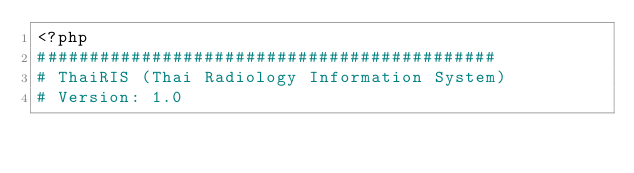Convert code to text. <code><loc_0><loc_0><loc_500><loc_500><_PHP_><?php
############################################
# ThaiRIS (Thai Radiology Information System)
# Version: 1.0</code> 